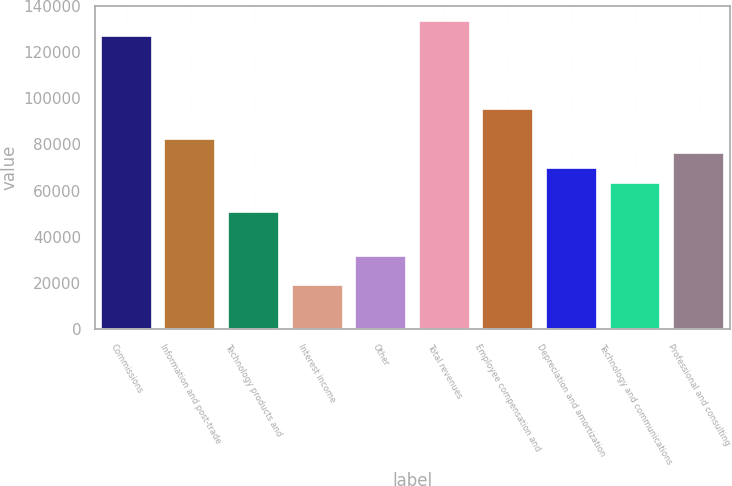Convert chart. <chart><loc_0><loc_0><loc_500><loc_500><bar_chart><fcel>Commissions<fcel>Information and post-trade<fcel>Technology products and<fcel>Interest income<fcel>Other<fcel>Total revenues<fcel>Employee compensation and<fcel>Depreciation and amortization<fcel>Technology and communications<fcel>Professional and consulting<nl><fcel>127014<fcel>82559<fcel>50805.7<fcel>19052.5<fcel>31753.8<fcel>133364<fcel>95260.3<fcel>69857.7<fcel>63507<fcel>76208.3<nl></chart> 